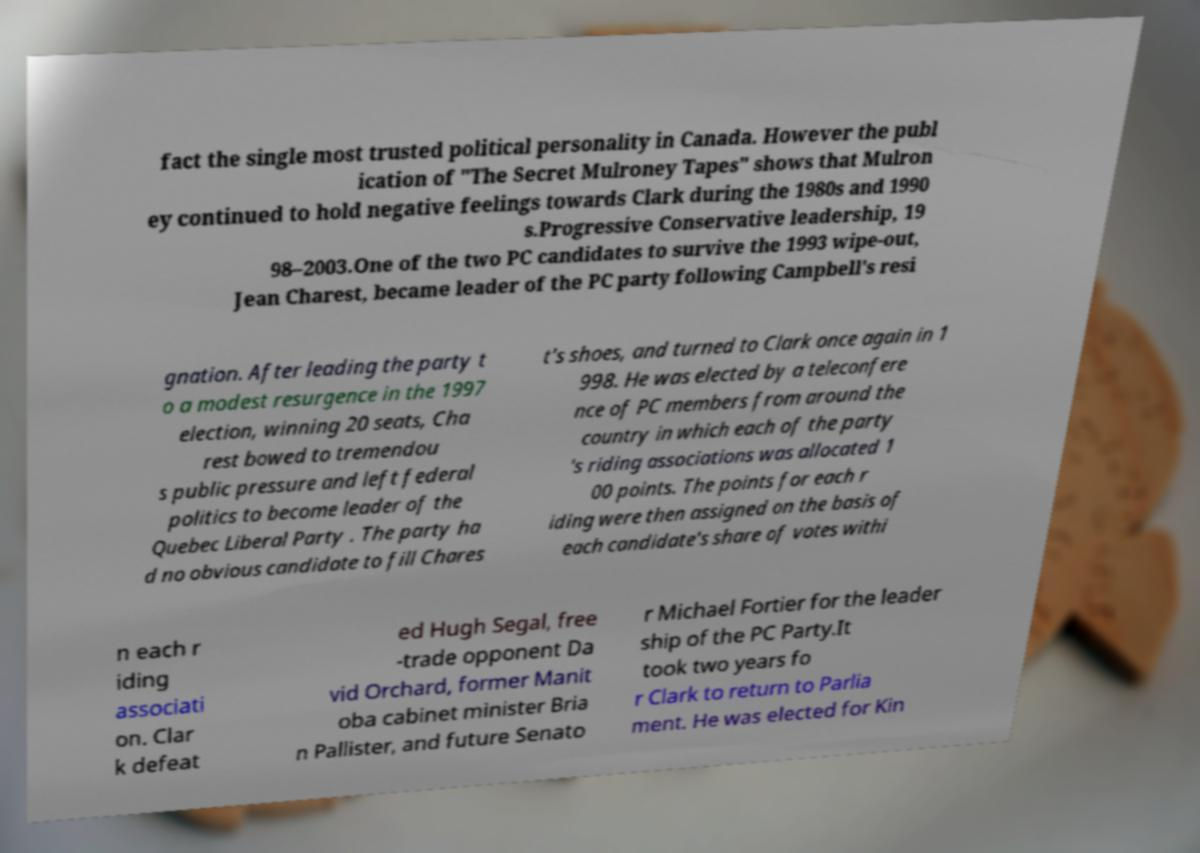What messages or text are displayed in this image? I need them in a readable, typed format. fact the single most trusted political personality in Canada. However the publ ication of "The Secret Mulroney Tapes" shows that Mulron ey continued to hold negative feelings towards Clark during the 1980s and 1990 s.Progressive Conservative leadership, 19 98–2003.One of the two PC candidates to survive the 1993 wipe-out, Jean Charest, became leader of the PC party following Campbell's resi gnation. After leading the party t o a modest resurgence in the 1997 election, winning 20 seats, Cha rest bowed to tremendou s public pressure and left federal politics to become leader of the Quebec Liberal Party . The party ha d no obvious candidate to fill Chares t's shoes, and turned to Clark once again in 1 998. He was elected by a teleconfere nce of PC members from around the country in which each of the party 's riding associations was allocated 1 00 points. The points for each r iding were then assigned on the basis of each candidate's share of votes withi n each r iding associati on. Clar k defeat ed Hugh Segal, free -trade opponent Da vid Orchard, former Manit oba cabinet minister Bria n Pallister, and future Senato r Michael Fortier for the leader ship of the PC Party.It took two years fo r Clark to return to Parlia ment. He was elected for Kin 